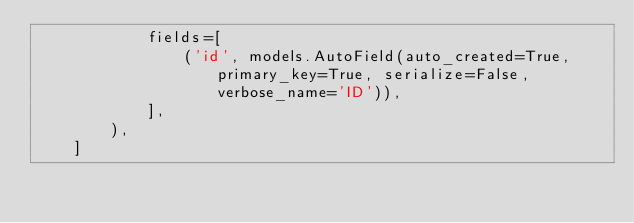<code> <loc_0><loc_0><loc_500><loc_500><_Python_>            fields=[
                ('id', models.AutoField(auto_created=True, primary_key=True, serialize=False, verbose_name='ID')),
            ],
        ),
    ]
</code> 